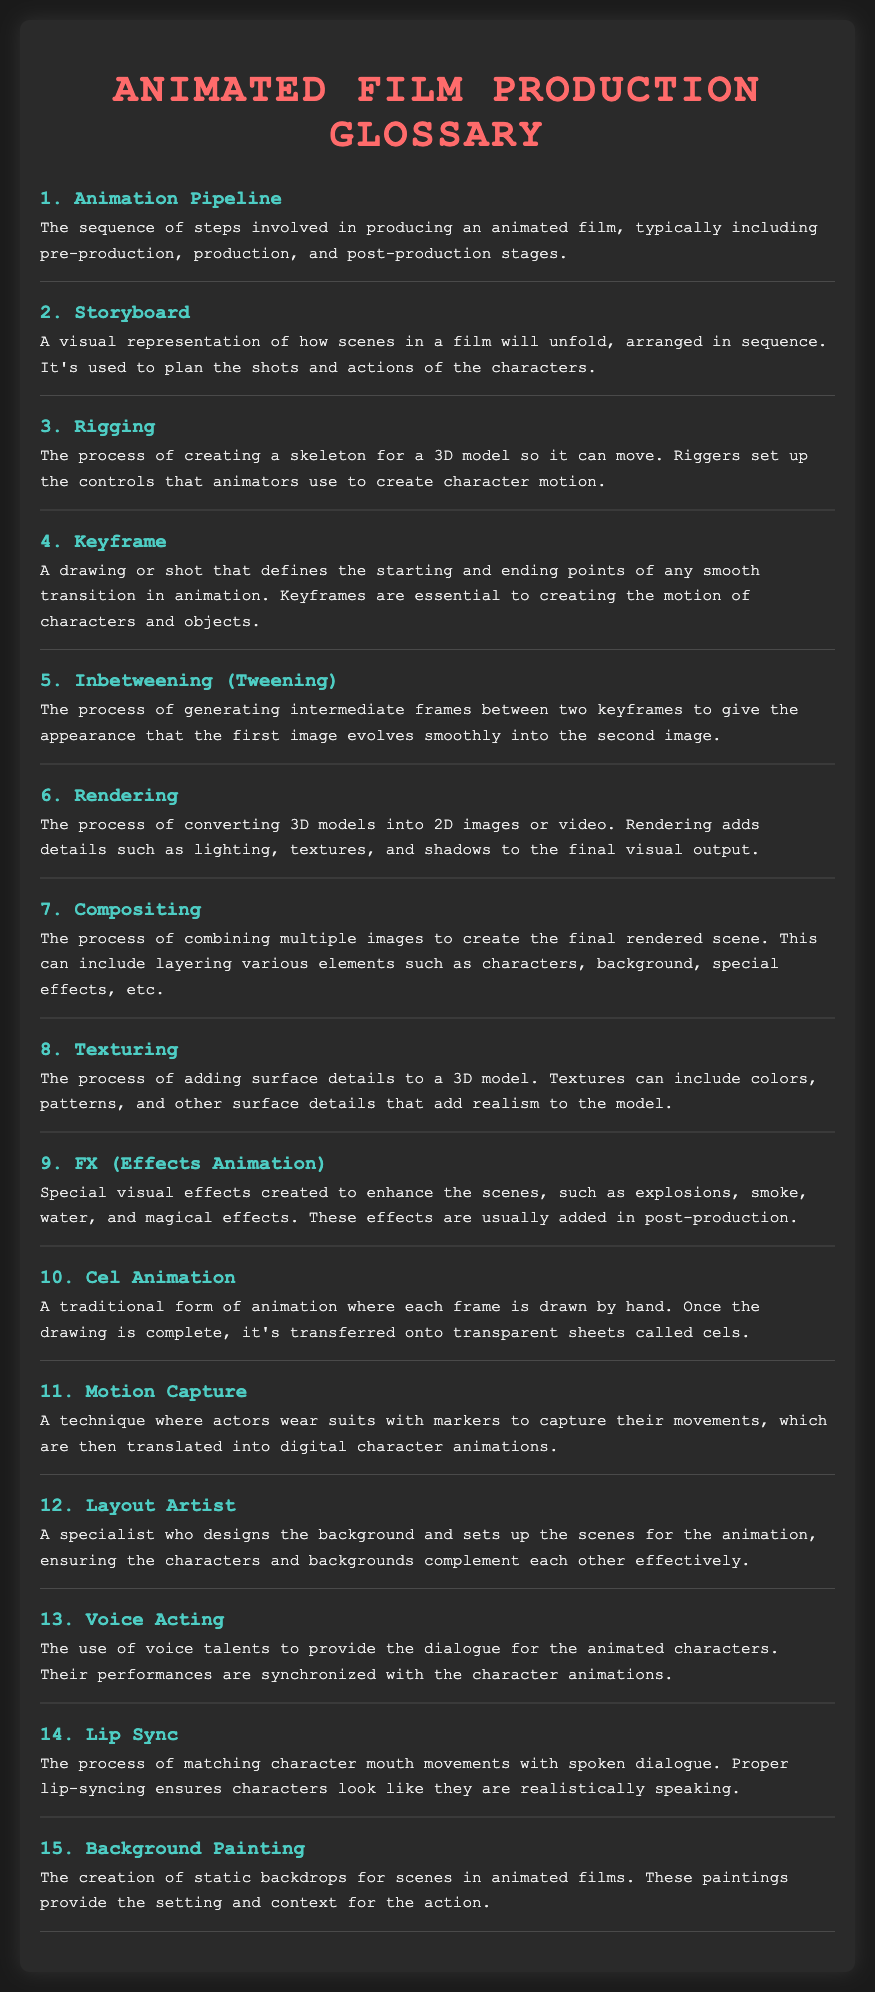What is the first term in the glossary? The first term is the first item listed in the glossary document.
Answer: Animation Pipeline How many key terms are listed in the glossary? The total number of key terms is given by the count of glossary items.
Answer: 15 What does "Cel Animation" refer to? The definition of "Cel Animation" is provided in the glossary as a specific term.
Answer: A traditional form of animation where each frame is drawn by hand What stage comes after production in the animation pipeline? The sequence of steps in the animation pipeline is provided in the glossary, and the stage after production is specified there.
Answer: Post-production What is the purpose of a storyboard? The glossary provides a specific definition outlining the role of a storyboard in filmmaking.
Answer: To plan the shots and actions of the characters Who is responsible for designing backgrounds in animated films? The glossary specifies the role responsible for designing backgrounds in animated films.
Answer: Layout Artist What technique captures an actor's movements for animation? The glossary includes a term that describes the technique of capturing movements, which can be found in the definitions.
Answer: Motion Capture How are lip movements matched with dialogue in animation? The glossary defines a process that involves synchronizing mouth movements with dialogue.
Answer: Lip Sync 